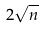<formula> <loc_0><loc_0><loc_500><loc_500>2 \sqrt { n }</formula> 